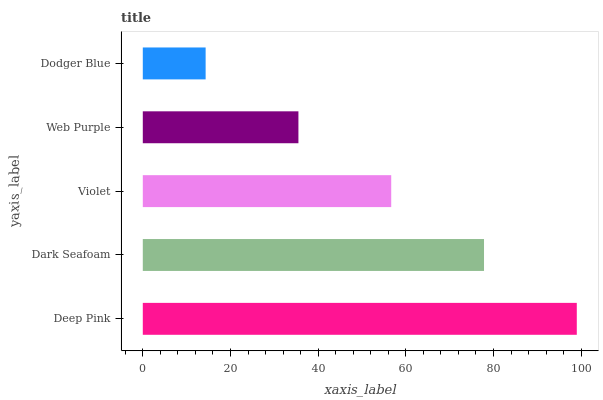Is Dodger Blue the minimum?
Answer yes or no. Yes. Is Deep Pink the maximum?
Answer yes or no. Yes. Is Dark Seafoam the minimum?
Answer yes or no. No. Is Dark Seafoam the maximum?
Answer yes or no. No. Is Deep Pink greater than Dark Seafoam?
Answer yes or no. Yes. Is Dark Seafoam less than Deep Pink?
Answer yes or no. Yes. Is Dark Seafoam greater than Deep Pink?
Answer yes or no. No. Is Deep Pink less than Dark Seafoam?
Answer yes or no. No. Is Violet the high median?
Answer yes or no. Yes. Is Violet the low median?
Answer yes or no. Yes. Is Dodger Blue the high median?
Answer yes or no. No. Is Deep Pink the low median?
Answer yes or no. No. 